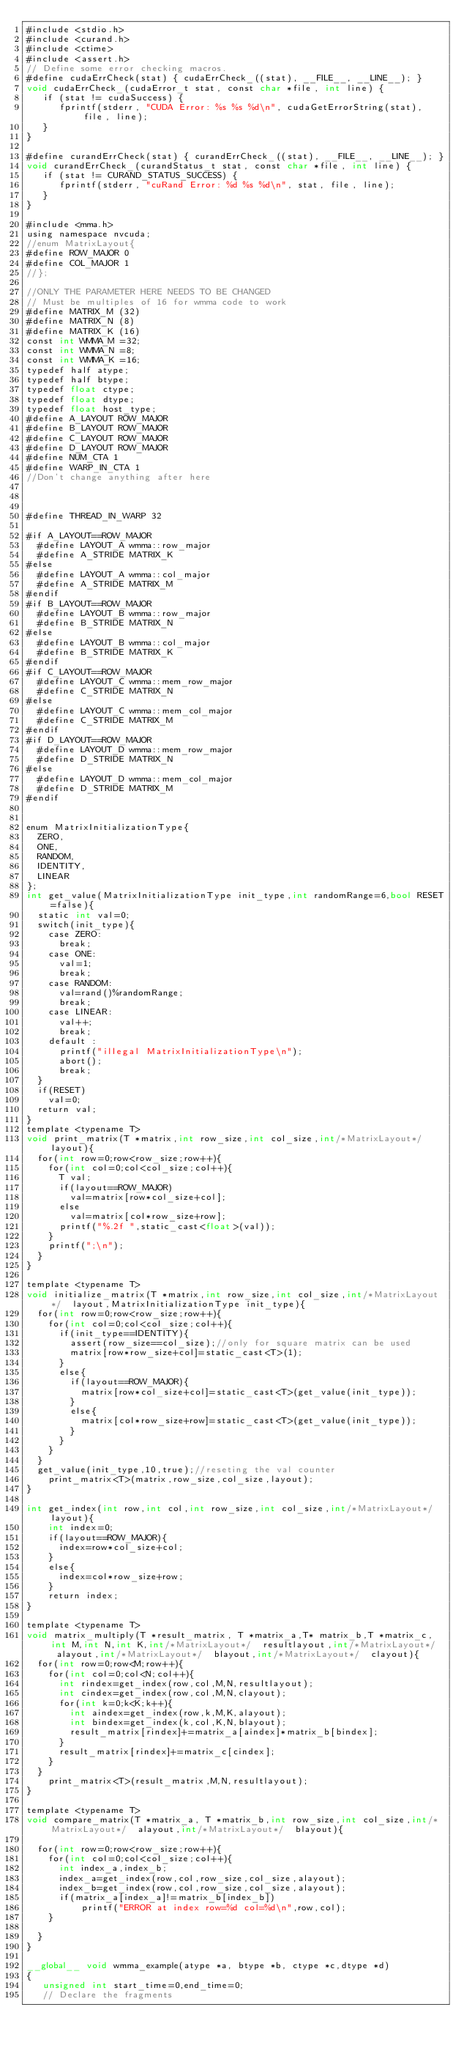Convert code to text. <code><loc_0><loc_0><loc_500><loc_500><_Cuda_>#include <stdio.h>
#include <curand.h>
#include <ctime>
#include <assert.h>
// Define some error checking macros.
#define cudaErrCheck(stat) { cudaErrCheck_((stat), __FILE__, __LINE__); }
void cudaErrCheck_(cudaError_t stat, const char *file, int line) {
   if (stat != cudaSuccess) {
      fprintf(stderr, "CUDA Error: %s %s %d\n", cudaGetErrorString(stat), file, line);
   }
}

#define curandErrCheck(stat) { curandErrCheck_((stat), __FILE__, __LINE__); }
void curandErrCheck_(curandStatus_t stat, const char *file, int line) {
   if (stat != CURAND_STATUS_SUCCESS) {
      fprintf(stderr, "cuRand Error: %d %s %d\n", stat, file, line);
   }
}

#include <mma.h>
using namespace nvcuda;
//enum MatrixLayout{
#define ROW_MAJOR 0
#define COL_MAJOR 1
//};

//ONLY THE PARAMETER HERE NEEDS TO BE CHANGED
// Must be multiples of 16 for wmma code to work
#define MATRIX_M (32)
#define MATRIX_N (8)
#define MATRIX_K (16)
const int WMMA_M =32;
const int WMMA_N =8;
const int WMMA_K =16;
typedef half atype;
typedef half btype;
typedef float ctype;
typedef float dtype;
typedef float host_type;
#define A_LAYOUT ROW_MAJOR
#define B_LAYOUT ROW_MAJOR 
#define C_LAYOUT ROW_MAJOR
#define D_LAYOUT ROW_MAJOR
#define NUM_CTA 1
#define WARP_IN_CTA 1
//Don't change anything after here 



#define THREAD_IN_WARP 32

#if A_LAYOUT==ROW_MAJOR
	#define LAYOUT_A wmma::row_major 
	#define A_STRIDE MATRIX_K
#else
	#define LAYOUT_A wmma::col_major 
	#define A_STRIDE MATRIX_M
#endif	
#if B_LAYOUT==ROW_MAJOR
	#define LAYOUT_B wmma::row_major 
	#define B_STRIDE MATRIX_N
#else
	#define LAYOUT_B wmma::col_major 
	#define B_STRIDE MATRIX_K
#endif	
#if C_LAYOUT==ROW_MAJOR
	#define LAYOUT_C wmma::mem_row_major 
	#define C_STRIDE MATRIX_N
#else
	#define LAYOUT_C wmma::mem_col_major 
	#define C_STRIDE MATRIX_M
#endif	
#if D_LAYOUT==ROW_MAJOR
	#define LAYOUT_D wmma::mem_row_major 
	#define D_STRIDE MATRIX_N
#else
	#define LAYOUT_D wmma::mem_col_major 
	#define D_STRIDE MATRIX_M
#endif	


enum MatrixInitializationType{
	ZERO,
	ONE,
	RANDOM,
	IDENTITY,
	LINEAR
};
int get_value(MatrixInitializationType init_type,int randomRange=6,bool RESET=false){
	static int val=0;
	switch(init_type){
		case ZERO:
			break;
		case ONE:
			val=1;
			break;
		case RANDOM:
			val=rand()%randomRange;
			break;
		case LINEAR:
			val++;
			break;
		default :
			printf("illegal MatrixInitializationType\n");
			abort();
			break;
	}
	if(RESET)
		val=0;
	return val;
}
template <typename T>
void print_matrix(T *matrix,int row_size,int col_size,int/*MatrixLayout*/  layout){
	for(int row=0;row<row_size;row++){
		for(int col=0;col<col_size;col++){
			T val;
			if(layout==ROW_MAJOR)
				val=matrix[row*col_size+col];		
			else
				val=matrix[col*row_size+row];
			printf("%.2f ",static_cast<float>(val));
		}
		printf(";\n");
	}
}

template <typename T>
void initialize_matrix(T *matrix,int row_size,int col_size,int/*MatrixLayout*/  layout,MatrixInitializationType init_type){
	for(int row=0;row<row_size;row++){
		for(int col=0;col<col_size;col++){
			if(init_type==IDENTITY){
				assert(row_size==col_size);//only for square matrix can be used
				matrix[row*row_size+col]=static_cast<T>(1);
			}
			else{
				if(layout==ROW_MAJOR){
					matrix[row*col_size+col]=static_cast<T>(get_value(init_type));
				}
				else{
					matrix[col*row_size+row]=static_cast<T>(get_value(init_type));
				}
			}
		}
	}
	get_value(init_type,10,true);//reseting the val counter
  	print_matrix<T>(matrix,row_size,col_size,layout);
}

int get_index(int row,int col,int row_size,int col_size,int/*MatrixLayout*/  layout){
		int index=0;
		if(layout==ROW_MAJOR){
			index=row*col_size+col;		
		}
		else{
			index=col*row_size+row;
		}
		return index;
}

template <typename T>
void matrix_multiply(T *result_matrix, T *matrix_a,T* matrix_b,T *matrix_c,int M,int N,int K,int/*MatrixLayout*/  resultlayout,int/*MatrixLayout*/  alayout,int/*MatrixLayout*/  blayout,int/*MatrixLayout*/  clayout){
	for(int row=0;row<M;row++){
		for(int col=0;col<N;col++){
			int rindex=get_index(row,col,M,N,resultlayout);
			int cindex=get_index(row,col,M,N,clayout);
			for(int k=0;k<K;k++){
				int aindex=get_index(row,k,M,K,alayout);
				int bindex=get_index(k,col,K,N,blayout);
				result_matrix[rindex]+=matrix_a[aindex]*matrix_b[bindex];
			}
			result_matrix[rindex]+=matrix_c[cindex];
		}
	}
   	print_matrix<T>(result_matrix,M,N,resultlayout);
}

template <typename T>	
void compare_matrix(T *matrix_a, T *matrix_b,int row_size,int col_size,int/*MatrixLayout*/  alayout,int/*MatrixLayout*/  blayout){
	
	for(int row=0;row<row_size;row++){
		for(int col=0;col<col_size;col++){
			int index_a,index_b;
			index_a=get_index(row,col,row_size,col_size,alayout);
			index_b=get_index(row,col,row_size,col_size,alayout);
			if(matrix_a[index_a]!=matrix_b[index_b])
					printf("ERROR at index row=%d col=%d\n",row,col);
		}
				
	}
}

__global__ void wmma_example(atype *a, btype *b, ctype *c,dtype *d)
{
   unsigned int start_time=0,end_time=0;
   // Declare the fragments</code> 